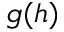Convert formula to latex. <formula><loc_0><loc_0><loc_500><loc_500>g ( h )</formula> 